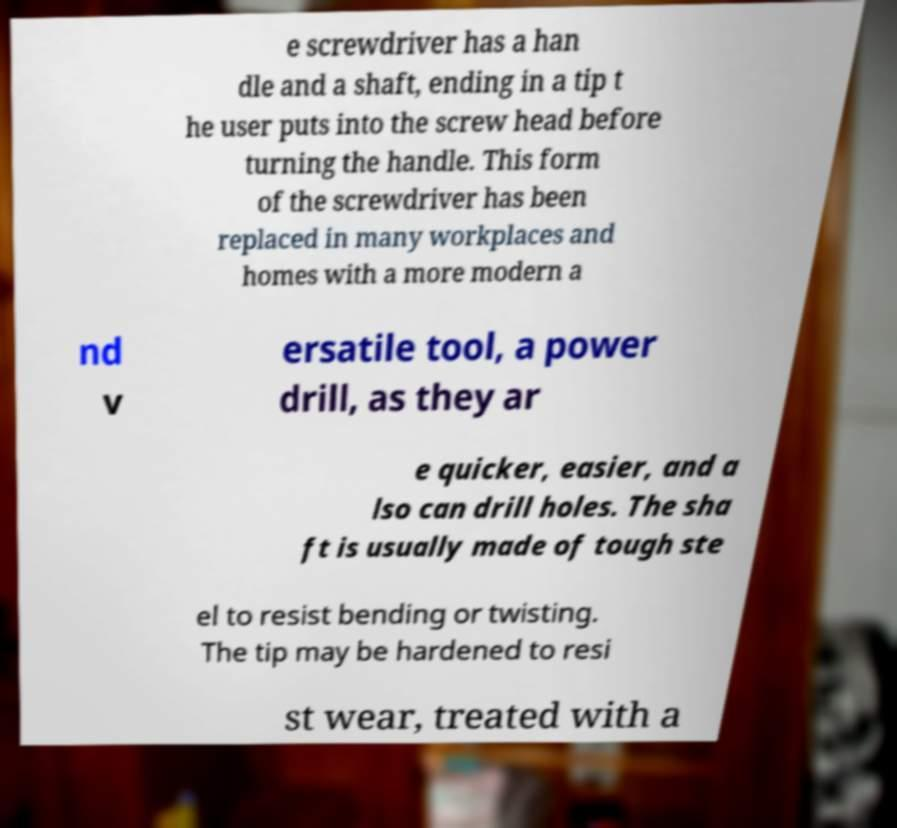There's text embedded in this image that I need extracted. Can you transcribe it verbatim? e screwdriver has a han dle and a shaft, ending in a tip t he user puts into the screw head before turning the handle. This form of the screwdriver has been replaced in many workplaces and homes with a more modern a nd v ersatile tool, a power drill, as they ar e quicker, easier, and a lso can drill holes. The sha ft is usually made of tough ste el to resist bending or twisting. The tip may be hardened to resi st wear, treated with a 